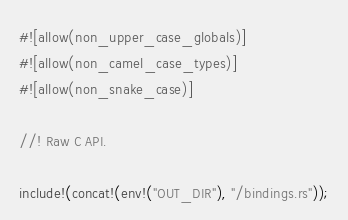Convert code to text. <code><loc_0><loc_0><loc_500><loc_500><_Rust_>#![allow(non_upper_case_globals)]
#![allow(non_camel_case_types)]
#![allow(non_snake_case)]

//! Raw C API.

include!(concat!(env!("OUT_DIR"), "/bindings.rs"));</code> 